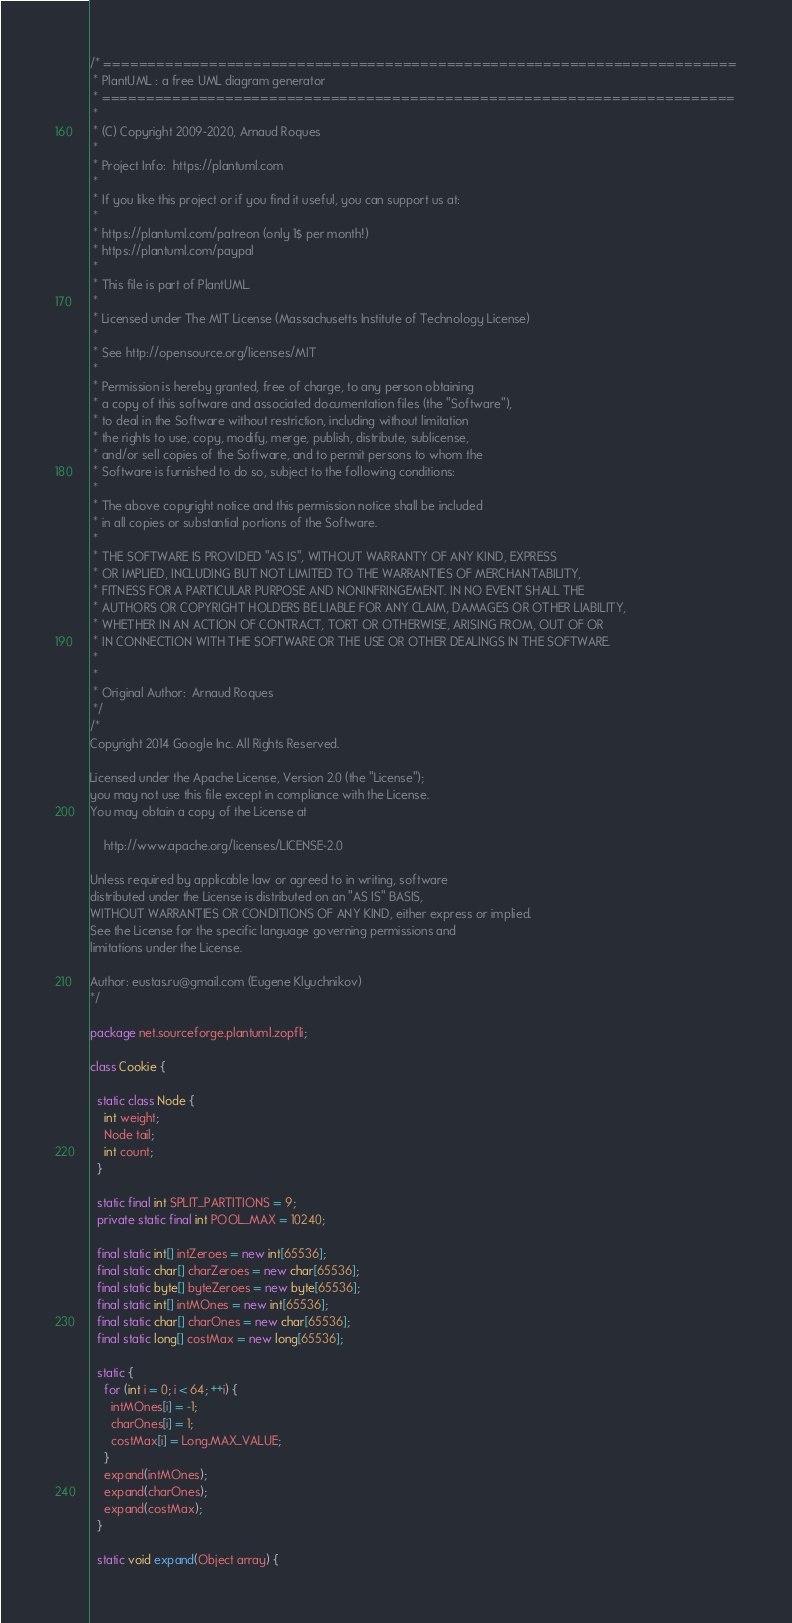<code> <loc_0><loc_0><loc_500><loc_500><_Java_>/* ========================================================================
 * PlantUML : a free UML diagram generator
 * ========================================================================
 *
 * (C) Copyright 2009-2020, Arnaud Roques
 *
 * Project Info:  https://plantuml.com
 * 
 * If you like this project or if you find it useful, you can support us at:
 * 
 * https://plantuml.com/patreon (only 1$ per month!)
 * https://plantuml.com/paypal
 * 
 * This file is part of PlantUML.
 *
 * Licensed under The MIT License (Massachusetts Institute of Technology License)
 * 
 * See http://opensource.org/licenses/MIT
 * 
 * Permission is hereby granted, free of charge, to any person obtaining
 * a copy of this software and associated documentation files (the "Software"),
 * to deal in the Software without restriction, including without limitation
 * the rights to use, copy, modify, merge, publish, distribute, sublicense,
 * and/or sell copies of the Software, and to permit persons to whom the
 * Software is furnished to do so, subject to the following conditions:
 * 
 * The above copyright notice and this permission notice shall be included
 * in all copies or substantial portions of the Software.
 * 
 * THE SOFTWARE IS PROVIDED "AS IS", WITHOUT WARRANTY OF ANY KIND, EXPRESS
 * OR IMPLIED, INCLUDING BUT NOT LIMITED TO THE WARRANTIES OF MERCHANTABILITY,
 * FITNESS FOR A PARTICULAR PURPOSE AND NONINFRINGEMENT. IN NO EVENT SHALL THE
 * AUTHORS OR COPYRIGHT HOLDERS BE LIABLE FOR ANY CLAIM, DAMAGES OR OTHER LIABILITY,
 * WHETHER IN AN ACTION OF CONTRACT, TORT OR OTHERWISE, ARISING FROM, OUT OF OR
 * IN CONNECTION WITH THE SOFTWARE OR THE USE OR OTHER DEALINGS IN THE SOFTWARE.
 * 
 *
 * Original Author:  Arnaud Roques
 */
/*
Copyright 2014 Google Inc. All Rights Reserved.

Licensed under the Apache License, Version 2.0 (the "License");
you may not use this file except in compliance with the License.
You may obtain a copy of the License at

    http://www.apache.org/licenses/LICENSE-2.0

Unless required by applicable law or agreed to in writing, software
distributed under the License is distributed on an "AS IS" BASIS,
WITHOUT WARRANTIES OR CONDITIONS OF ANY KIND, either express or implied.
See the License for the specific language governing permissions and
limitations under the License.

Author: eustas.ru@gmail.com (Eugene Klyuchnikov)
*/

package net.sourceforge.plantuml.zopfli;

class Cookie {

  static class Node {
    int weight;
    Node tail;
    int count;
  }

  static final int SPLIT_PARTITIONS = 9;
  private static final int POOL_MAX = 10240;

  final static int[] intZeroes = new int[65536];
  final static char[] charZeroes = new char[65536];
  final static byte[] byteZeroes = new byte[65536];
  final static int[] intMOnes = new int[65536];
  final static char[] charOnes = new char[65536];
  final static long[] costMax = new long[65536];

  static {
    for (int i = 0; i < 64; ++i) {
      intMOnes[i] = -1;
      charOnes[i] = 1;
      costMax[i] = Long.MAX_VALUE;
    }
    expand(intMOnes);
    expand(charOnes);
    expand(costMax);
  }

  static void expand(Object array) {</code> 